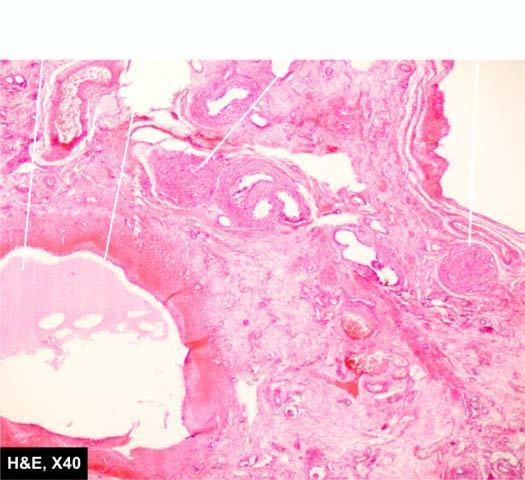does the intervening parenchyma consist of primitive connective tissue and cartilage?
Answer the question using a single word or phrase. Yes 